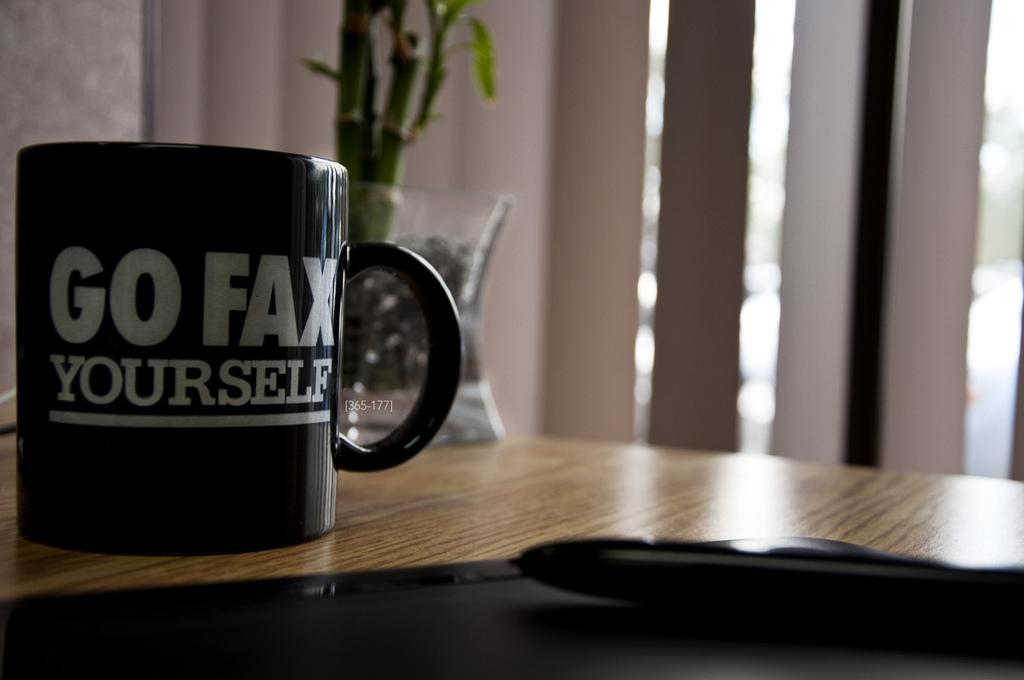What is located at the bottom of the image? There is a table at the bottom of the image. What can be found on the table? A cup, a pot, and a plant are on the table, along with other objects. Can you describe the background of the image? There is a wall visible in the background of the image. How does the plant receive a haircut in the image? There is no indication in the image that the plant is receiving a haircut, and plants do not require haircuts. 